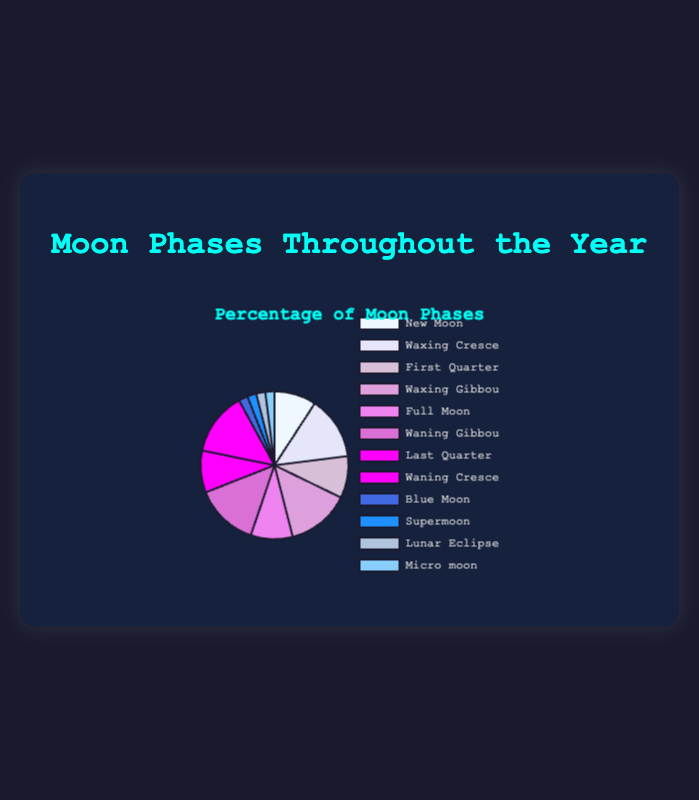Which moon phase has the highest percentage throughout the year? From the figure, Waxing Crescent, Waxing Gibbous, Waning Gibbous, and Waning Crescent each have a percentage of 12.5%, which are the highest.
Answer: Waxing Crescent, Waxing Gibbous, Waning Gibbous, Waning Crescent How many moon phases have a percentage less than 5%? The figure shows Blue Moon, Supermoon, Lunar Eclipse, and Micro moon each have 1.8%. All these are less than 5%. Hence, there are four phases.
Answer: 4 What is the combined percentage of all the moon phases that have exactly 8.3%? The figure shows that New Moon, First Quarter, Full Moon, and Last Quarter each have a percentage of 8.3%. Summing them gives 4 * 8.3 = 33.2%.
Answer: 33.2% Are there more moon phases with 12.5% or 1.8%? Four moon phases each have 12.5% (Waxing Crescent, Waxing Gibbous, Waning Gibbous, and Waning Crescent), while four phases each have 1.8% (Blue Moon, Supermoon, Lunar Eclipse, Micro moon). Thus, their numbers are equal.
Answer: Equal What is the average percentage of all the moon phases? The percentages add up to 8.3 * 4 + 12.5 * 4 + 1.8 * 4 = 33.2 + 50 + 7.2 = 90.4%. Dividing by 12 moon phases gives an average of 90.4 / 12 = 7.533%.
Answer: 7.533% Which moon phase(s) share the same color in the figure? The moon phases Waning Crescent and First Quarter are both represented by the same magenta color.
Answer: Waning Crescent, First Quarter What fraction of the year does the New Moon phase cover? From the figure, New Moon covers a percentage of 8.3%. To convert the percentage to a fraction, we have 8.3/100 = 0.083.
Answer: 0.083 Compare the combined percentage of phases with a percentage of 12.5% to that with 8.3%. Which one is higher and by how much? The sum of percentages for 12.5% phases is 12.5 * 4 = 50%, and for 8.3% phases is 8.3 * 4 = 33.2%. The difference is 50% - 33.2% = 16.8%.
Answer: 12.5% phases by 16.8% What is the predominant color on the pie chart? Observing the color distribution, the shades of magenta represent four phases: Waxing Crescent, Waxing Gibbous, Waning Gibbous, and Waning Crescent with 12.5% each, making it the predominant color.
Answer: Magenta 